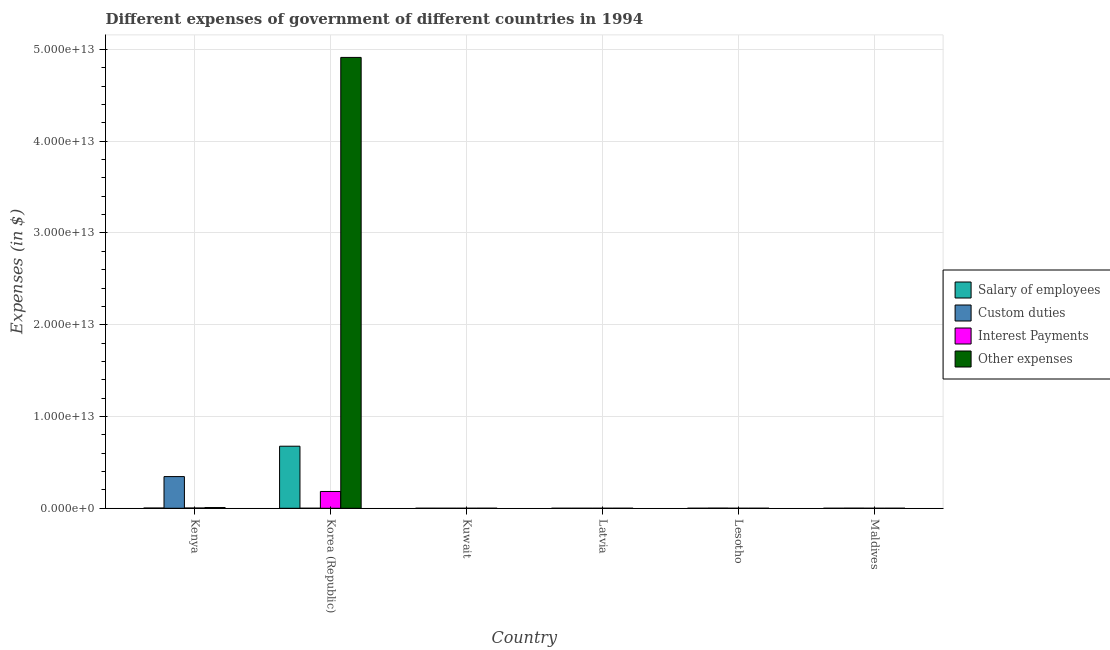How many groups of bars are there?
Your answer should be very brief. 6. What is the label of the 3rd group of bars from the left?
Provide a succinct answer. Kuwait. What is the amount spent on interest payments in Lesotho?
Offer a terse response. 4.94e+07. Across all countries, what is the maximum amount spent on other expenses?
Give a very brief answer. 4.91e+13. Across all countries, what is the minimum amount spent on salary of employees?
Make the answer very short. 9.94e+07. In which country was the amount spent on custom duties maximum?
Provide a succinct answer. Kenya. In which country was the amount spent on interest payments minimum?
Keep it short and to the point. Latvia. What is the total amount spent on other expenses in the graph?
Give a very brief answer. 4.92e+13. What is the difference between the amount spent on salary of employees in Korea (Republic) and that in Lesotho?
Give a very brief answer. 6.76e+12. What is the difference between the amount spent on custom duties in Maldives and the amount spent on salary of employees in Latvia?
Offer a terse response. 7.44e+09. What is the average amount spent on interest payments per country?
Offer a very short reply. 3.10e+11. What is the difference between the amount spent on interest payments and amount spent on custom duties in Maldives?
Offer a very short reply. -7.48e+09. What is the ratio of the amount spent on salary of employees in Kuwait to that in Latvia?
Ensure brevity in your answer.  11.14. Is the difference between the amount spent on other expenses in Kenya and Kuwait greater than the difference between the amount spent on custom duties in Kenya and Kuwait?
Keep it short and to the point. No. What is the difference between the highest and the second highest amount spent on salary of employees?
Provide a succinct answer. 6.74e+12. What is the difference between the highest and the lowest amount spent on interest payments?
Offer a terse response. 1.83e+12. In how many countries, is the amount spent on other expenses greater than the average amount spent on other expenses taken over all countries?
Provide a short and direct response. 1. Is the sum of the amount spent on salary of employees in Kenya and Latvia greater than the maximum amount spent on interest payments across all countries?
Make the answer very short. No. Is it the case that in every country, the sum of the amount spent on interest payments and amount spent on salary of employees is greater than the sum of amount spent on custom duties and amount spent on other expenses?
Keep it short and to the point. No. What does the 2nd bar from the left in Lesotho represents?
Your response must be concise. Custom duties. What does the 2nd bar from the right in Latvia represents?
Ensure brevity in your answer.  Interest Payments. Is it the case that in every country, the sum of the amount spent on salary of employees and amount spent on custom duties is greater than the amount spent on interest payments?
Your answer should be very brief. Yes. Are all the bars in the graph horizontal?
Ensure brevity in your answer.  No. What is the difference between two consecutive major ticks on the Y-axis?
Provide a succinct answer. 1.00e+13. Does the graph contain any zero values?
Your answer should be very brief. No. Where does the legend appear in the graph?
Make the answer very short. Center right. How are the legend labels stacked?
Offer a very short reply. Vertical. What is the title of the graph?
Ensure brevity in your answer.  Different expenses of government of different countries in 1994. Does "Secondary vocational" appear as one of the legend labels in the graph?
Your response must be concise. No. What is the label or title of the Y-axis?
Your response must be concise. Expenses (in $). What is the Expenses (in $) of Salary of employees in Kenya?
Give a very brief answer. 2.49e+1. What is the Expenses (in $) in Custom duties in Kenya?
Make the answer very short. 3.45e+12. What is the Expenses (in $) in Interest Payments in Kenya?
Offer a very short reply. 2.79e+1. What is the Expenses (in $) in Other expenses in Kenya?
Provide a succinct answer. 7.84e+1. What is the Expenses (in $) of Salary of employees in Korea (Republic)?
Offer a very short reply. 6.76e+12. What is the Expenses (in $) of Custom duties in Korea (Republic)?
Offer a terse response. 6.80e+07. What is the Expenses (in $) of Interest Payments in Korea (Republic)?
Your answer should be compact. 1.83e+12. What is the Expenses (in $) of Other expenses in Korea (Republic)?
Give a very brief answer. 4.91e+13. What is the Expenses (in $) of Salary of employees in Kuwait?
Ensure brevity in your answer.  1.11e+09. What is the Expenses (in $) of Custom duties in Kuwait?
Your response must be concise. 2.34e+07. What is the Expenses (in $) in Interest Payments in Kuwait?
Make the answer very short. 3.96e+08. What is the Expenses (in $) in Other expenses in Kuwait?
Offer a terse response. 3.63e+09. What is the Expenses (in $) of Salary of employees in Latvia?
Your answer should be compact. 9.94e+07. What is the Expenses (in $) of Custom duties in Latvia?
Provide a succinct answer. 3.40e+08. What is the Expenses (in $) of Interest Payments in Latvia?
Provide a succinct answer. 8.72e+06. What is the Expenses (in $) in Other expenses in Latvia?
Give a very brief answer. 5.43e+08. What is the Expenses (in $) of Salary of employees in Lesotho?
Provide a short and direct response. 4.60e+08. What is the Expenses (in $) of Custom duties in Lesotho?
Give a very brief answer. 1.27e+1. What is the Expenses (in $) in Interest Payments in Lesotho?
Ensure brevity in your answer.  4.94e+07. What is the Expenses (in $) in Other expenses in Lesotho?
Provide a short and direct response. 1.05e+09. What is the Expenses (in $) in Salary of employees in Maldives?
Keep it short and to the point. 1.85e+08. What is the Expenses (in $) in Custom duties in Maldives?
Keep it short and to the point. 7.54e+09. What is the Expenses (in $) in Interest Payments in Maldives?
Your response must be concise. 5.61e+07. What is the Expenses (in $) of Other expenses in Maldives?
Make the answer very short. 6.92e+08. Across all countries, what is the maximum Expenses (in $) of Salary of employees?
Your answer should be very brief. 6.76e+12. Across all countries, what is the maximum Expenses (in $) of Custom duties?
Your response must be concise. 3.45e+12. Across all countries, what is the maximum Expenses (in $) of Interest Payments?
Your answer should be compact. 1.83e+12. Across all countries, what is the maximum Expenses (in $) in Other expenses?
Your answer should be very brief. 4.91e+13. Across all countries, what is the minimum Expenses (in $) of Salary of employees?
Ensure brevity in your answer.  9.94e+07. Across all countries, what is the minimum Expenses (in $) in Custom duties?
Offer a very short reply. 2.34e+07. Across all countries, what is the minimum Expenses (in $) of Interest Payments?
Ensure brevity in your answer.  8.72e+06. Across all countries, what is the minimum Expenses (in $) of Other expenses?
Offer a very short reply. 5.43e+08. What is the total Expenses (in $) of Salary of employees in the graph?
Ensure brevity in your answer.  6.79e+12. What is the total Expenses (in $) of Custom duties in the graph?
Give a very brief answer. 3.47e+12. What is the total Expenses (in $) of Interest Payments in the graph?
Provide a short and direct response. 1.86e+12. What is the total Expenses (in $) in Other expenses in the graph?
Give a very brief answer. 4.92e+13. What is the difference between the Expenses (in $) in Salary of employees in Kenya and that in Korea (Republic)?
Provide a short and direct response. -6.74e+12. What is the difference between the Expenses (in $) in Custom duties in Kenya and that in Korea (Republic)?
Ensure brevity in your answer.  3.45e+12. What is the difference between the Expenses (in $) in Interest Payments in Kenya and that in Korea (Republic)?
Offer a very short reply. -1.80e+12. What is the difference between the Expenses (in $) in Other expenses in Kenya and that in Korea (Republic)?
Your answer should be compact. -4.90e+13. What is the difference between the Expenses (in $) in Salary of employees in Kenya and that in Kuwait?
Give a very brief answer. 2.38e+1. What is the difference between the Expenses (in $) of Custom duties in Kenya and that in Kuwait?
Provide a short and direct response. 3.45e+12. What is the difference between the Expenses (in $) of Interest Payments in Kenya and that in Kuwait?
Give a very brief answer. 2.75e+1. What is the difference between the Expenses (in $) in Other expenses in Kenya and that in Kuwait?
Give a very brief answer. 7.48e+1. What is the difference between the Expenses (in $) of Salary of employees in Kenya and that in Latvia?
Provide a succinct answer. 2.48e+1. What is the difference between the Expenses (in $) in Custom duties in Kenya and that in Latvia?
Make the answer very short. 3.45e+12. What is the difference between the Expenses (in $) of Interest Payments in Kenya and that in Latvia?
Give a very brief answer. 2.78e+1. What is the difference between the Expenses (in $) in Other expenses in Kenya and that in Latvia?
Keep it short and to the point. 7.79e+1. What is the difference between the Expenses (in $) in Salary of employees in Kenya and that in Lesotho?
Provide a short and direct response. 2.44e+1. What is the difference between the Expenses (in $) in Custom duties in Kenya and that in Lesotho?
Offer a very short reply. 3.44e+12. What is the difference between the Expenses (in $) of Interest Payments in Kenya and that in Lesotho?
Keep it short and to the point. 2.78e+1. What is the difference between the Expenses (in $) in Other expenses in Kenya and that in Lesotho?
Your response must be concise. 7.74e+1. What is the difference between the Expenses (in $) in Salary of employees in Kenya and that in Maldives?
Keep it short and to the point. 2.47e+1. What is the difference between the Expenses (in $) in Custom duties in Kenya and that in Maldives?
Provide a succinct answer. 3.45e+12. What is the difference between the Expenses (in $) in Interest Payments in Kenya and that in Maldives?
Offer a very short reply. 2.78e+1. What is the difference between the Expenses (in $) of Other expenses in Kenya and that in Maldives?
Ensure brevity in your answer.  7.77e+1. What is the difference between the Expenses (in $) in Salary of employees in Korea (Republic) and that in Kuwait?
Your answer should be compact. 6.76e+12. What is the difference between the Expenses (in $) in Custom duties in Korea (Republic) and that in Kuwait?
Your answer should be compact. 4.46e+07. What is the difference between the Expenses (in $) of Interest Payments in Korea (Republic) and that in Kuwait?
Your answer should be compact. 1.83e+12. What is the difference between the Expenses (in $) in Other expenses in Korea (Republic) and that in Kuwait?
Provide a short and direct response. 4.91e+13. What is the difference between the Expenses (in $) of Salary of employees in Korea (Republic) and that in Latvia?
Ensure brevity in your answer.  6.76e+12. What is the difference between the Expenses (in $) of Custom duties in Korea (Republic) and that in Latvia?
Provide a short and direct response. -2.72e+08. What is the difference between the Expenses (in $) of Interest Payments in Korea (Republic) and that in Latvia?
Provide a short and direct response. 1.83e+12. What is the difference between the Expenses (in $) of Other expenses in Korea (Republic) and that in Latvia?
Give a very brief answer. 4.91e+13. What is the difference between the Expenses (in $) of Salary of employees in Korea (Republic) and that in Lesotho?
Your answer should be compact. 6.76e+12. What is the difference between the Expenses (in $) of Custom duties in Korea (Republic) and that in Lesotho?
Keep it short and to the point. -1.26e+1. What is the difference between the Expenses (in $) of Interest Payments in Korea (Republic) and that in Lesotho?
Provide a succinct answer. 1.83e+12. What is the difference between the Expenses (in $) in Other expenses in Korea (Republic) and that in Lesotho?
Provide a succinct answer. 4.91e+13. What is the difference between the Expenses (in $) of Salary of employees in Korea (Republic) and that in Maldives?
Your answer should be very brief. 6.76e+12. What is the difference between the Expenses (in $) of Custom duties in Korea (Republic) and that in Maldives?
Your answer should be compact. -7.47e+09. What is the difference between the Expenses (in $) of Interest Payments in Korea (Republic) and that in Maldives?
Ensure brevity in your answer.  1.83e+12. What is the difference between the Expenses (in $) of Other expenses in Korea (Republic) and that in Maldives?
Offer a very short reply. 4.91e+13. What is the difference between the Expenses (in $) of Salary of employees in Kuwait and that in Latvia?
Give a very brief answer. 1.01e+09. What is the difference between the Expenses (in $) in Custom duties in Kuwait and that in Latvia?
Your response must be concise. -3.17e+08. What is the difference between the Expenses (in $) of Interest Payments in Kuwait and that in Latvia?
Offer a very short reply. 3.87e+08. What is the difference between the Expenses (in $) in Other expenses in Kuwait and that in Latvia?
Provide a short and direct response. 3.09e+09. What is the difference between the Expenses (in $) in Salary of employees in Kuwait and that in Lesotho?
Make the answer very short. 6.48e+08. What is the difference between the Expenses (in $) in Custom duties in Kuwait and that in Lesotho?
Ensure brevity in your answer.  -1.27e+1. What is the difference between the Expenses (in $) in Interest Payments in Kuwait and that in Lesotho?
Make the answer very short. 3.47e+08. What is the difference between the Expenses (in $) of Other expenses in Kuwait and that in Lesotho?
Your answer should be compact. 2.58e+09. What is the difference between the Expenses (in $) of Salary of employees in Kuwait and that in Maldives?
Ensure brevity in your answer.  9.23e+08. What is the difference between the Expenses (in $) of Custom duties in Kuwait and that in Maldives?
Offer a very short reply. -7.52e+09. What is the difference between the Expenses (in $) in Interest Payments in Kuwait and that in Maldives?
Make the answer very short. 3.40e+08. What is the difference between the Expenses (in $) of Other expenses in Kuwait and that in Maldives?
Offer a terse response. 2.94e+09. What is the difference between the Expenses (in $) in Salary of employees in Latvia and that in Lesotho?
Offer a terse response. -3.60e+08. What is the difference between the Expenses (in $) of Custom duties in Latvia and that in Lesotho?
Keep it short and to the point. -1.24e+1. What is the difference between the Expenses (in $) in Interest Payments in Latvia and that in Lesotho?
Offer a very short reply. -4.07e+07. What is the difference between the Expenses (in $) in Other expenses in Latvia and that in Lesotho?
Offer a very short reply. -5.08e+08. What is the difference between the Expenses (in $) in Salary of employees in Latvia and that in Maldives?
Offer a very short reply. -8.55e+07. What is the difference between the Expenses (in $) of Custom duties in Latvia and that in Maldives?
Your response must be concise. -7.20e+09. What is the difference between the Expenses (in $) of Interest Payments in Latvia and that in Maldives?
Make the answer very short. -4.74e+07. What is the difference between the Expenses (in $) of Other expenses in Latvia and that in Maldives?
Your answer should be compact. -1.48e+08. What is the difference between the Expenses (in $) in Salary of employees in Lesotho and that in Maldives?
Keep it short and to the point. 2.75e+08. What is the difference between the Expenses (in $) of Custom duties in Lesotho and that in Maldives?
Provide a succinct answer. 5.17e+09. What is the difference between the Expenses (in $) in Interest Payments in Lesotho and that in Maldives?
Ensure brevity in your answer.  -6.70e+06. What is the difference between the Expenses (in $) of Other expenses in Lesotho and that in Maldives?
Make the answer very short. 3.59e+08. What is the difference between the Expenses (in $) of Salary of employees in Kenya and the Expenses (in $) of Custom duties in Korea (Republic)?
Your response must be concise. 2.48e+1. What is the difference between the Expenses (in $) of Salary of employees in Kenya and the Expenses (in $) of Interest Payments in Korea (Republic)?
Provide a succinct answer. -1.81e+12. What is the difference between the Expenses (in $) of Salary of employees in Kenya and the Expenses (in $) of Other expenses in Korea (Republic)?
Give a very brief answer. -4.91e+13. What is the difference between the Expenses (in $) in Custom duties in Kenya and the Expenses (in $) in Interest Payments in Korea (Republic)?
Offer a very short reply. 1.62e+12. What is the difference between the Expenses (in $) of Custom duties in Kenya and the Expenses (in $) of Other expenses in Korea (Republic)?
Give a very brief answer. -4.57e+13. What is the difference between the Expenses (in $) in Interest Payments in Kenya and the Expenses (in $) in Other expenses in Korea (Republic)?
Offer a very short reply. -4.91e+13. What is the difference between the Expenses (in $) in Salary of employees in Kenya and the Expenses (in $) in Custom duties in Kuwait?
Provide a succinct answer. 2.48e+1. What is the difference between the Expenses (in $) in Salary of employees in Kenya and the Expenses (in $) in Interest Payments in Kuwait?
Make the answer very short. 2.45e+1. What is the difference between the Expenses (in $) of Salary of employees in Kenya and the Expenses (in $) of Other expenses in Kuwait?
Make the answer very short. 2.12e+1. What is the difference between the Expenses (in $) of Custom duties in Kenya and the Expenses (in $) of Interest Payments in Kuwait?
Offer a very short reply. 3.45e+12. What is the difference between the Expenses (in $) of Custom duties in Kenya and the Expenses (in $) of Other expenses in Kuwait?
Your answer should be very brief. 3.45e+12. What is the difference between the Expenses (in $) in Interest Payments in Kenya and the Expenses (in $) in Other expenses in Kuwait?
Offer a terse response. 2.42e+1. What is the difference between the Expenses (in $) in Salary of employees in Kenya and the Expenses (in $) in Custom duties in Latvia?
Offer a very short reply. 2.45e+1. What is the difference between the Expenses (in $) in Salary of employees in Kenya and the Expenses (in $) in Interest Payments in Latvia?
Provide a short and direct response. 2.49e+1. What is the difference between the Expenses (in $) in Salary of employees in Kenya and the Expenses (in $) in Other expenses in Latvia?
Offer a terse response. 2.43e+1. What is the difference between the Expenses (in $) in Custom duties in Kenya and the Expenses (in $) in Interest Payments in Latvia?
Your answer should be compact. 3.45e+12. What is the difference between the Expenses (in $) of Custom duties in Kenya and the Expenses (in $) of Other expenses in Latvia?
Provide a succinct answer. 3.45e+12. What is the difference between the Expenses (in $) in Interest Payments in Kenya and the Expenses (in $) in Other expenses in Latvia?
Make the answer very short. 2.73e+1. What is the difference between the Expenses (in $) in Salary of employees in Kenya and the Expenses (in $) in Custom duties in Lesotho?
Keep it short and to the point. 1.22e+1. What is the difference between the Expenses (in $) of Salary of employees in Kenya and the Expenses (in $) of Interest Payments in Lesotho?
Offer a very short reply. 2.48e+1. What is the difference between the Expenses (in $) of Salary of employees in Kenya and the Expenses (in $) of Other expenses in Lesotho?
Ensure brevity in your answer.  2.38e+1. What is the difference between the Expenses (in $) in Custom duties in Kenya and the Expenses (in $) in Interest Payments in Lesotho?
Offer a very short reply. 3.45e+12. What is the difference between the Expenses (in $) of Custom duties in Kenya and the Expenses (in $) of Other expenses in Lesotho?
Provide a short and direct response. 3.45e+12. What is the difference between the Expenses (in $) of Interest Payments in Kenya and the Expenses (in $) of Other expenses in Lesotho?
Ensure brevity in your answer.  2.68e+1. What is the difference between the Expenses (in $) of Salary of employees in Kenya and the Expenses (in $) of Custom duties in Maldives?
Your answer should be very brief. 1.73e+1. What is the difference between the Expenses (in $) of Salary of employees in Kenya and the Expenses (in $) of Interest Payments in Maldives?
Your answer should be compact. 2.48e+1. What is the difference between the Expenses (in $) of Salary of employees in Kenya and the Expenses (in $) of Other expenses in Maldives?
Your answer should be very brief. 2.42e+1. What is the difference between the Expenses (in $) in Custom duties in Kenya and the Expenses (in $) in Interest Payments in Maldives?
Your response must be concise. 3.45e+12. What is the difference between the Expenses (in $) in Custom duties in Kenya and the Expenses (in $) in Other expenses in Maldives?
Offer a very short reply. 3.45e+12. What is the difference between the Expenses (in $) in Interest Payments in Kenya and the Expenses (in $) in Other expenses in Maldives?
Provide a succinct answer. 2.72e+1. What is the difference between the Expenses (in $) in Salary of employees in Korea (Republic) and the Expenses (in $) in Custom duties in Kuwait?
Your answer should be compact. 6.76e+12. What is the difference between the Expenses (in $) in Salary of employees in Korea (Republic) and the Expenses (in $) in Interest Payments in Kuwait?
Keep it short and to the point. 6.76e+12. What is the difference between the Expenses (in $) of Salary of employees in Korea (Republic) and the Expenses (in $) of Other expenses in Kuwait?
Make the answer very short. 6.76e+12. What is the difference between the Expenses (in $) of Custom duties in Korea (Republic) and the Expenses (in $) of Interest Payments in Kuwait?
Offer a very short reply. -3.28e+08. What is the difference between the Expenses (in $) of Custom duties in Korea (Republic) and the Expenses (in $) of Other expenses in Kuwait?
Provide a short and direct response. -3.57e+09. What is the difference between the Expenses (in $) in Interest Payments in Korea (Republic) and the Expenses (in $) in Other expenses in Kuwait?
Your answer should be very brief. 1.83e+12. What is the difference between the Expenses (in $) of Salary of employees in Korea (Republic) and the Expenses (in $) of Custom duties in Latvia?
Make the answer very short. 6.76e+12. What is the difference between the Expenses (in $) in Salary of employees in Korea (Republic) and the Expenses (in $) in Interest Payments in Latvia?
Keep it short and to the point. 6.76e+12. What is the difference between the Expenses (in $) of Salary of employees in Korea (Republic) and the Expenses (in $) of Other expenses in Latvia?
Your response must be concise. 6.76e+12. What is the difference between the Expenses (in $) in Custom duties in Korea (Republic) and the Expenses (in $) in Interest Payments in Latvia?
Your answer should be compact. 5.93e+07. What is the difference between the Expenses (in $) of Custom duties in Korea (Republic) and the Expenses (in $) of Other expenses in Latvia?
Make the answer very short. -4.75e+08. What is the difference between the Expenses (in $) in Interest Payments in Korea (Republic) and the Expenses (in $) in Other expenses in Latvia?
Your answer should be compact. 1.83e+12. What is the difference between the Expenses (in $) in Salary of employees in Korea (Republic) and the Expenses (in $) in Custom duties in Lesotho?
Give a very brief answer. 6.75e+12. What is the difference between the Expenses (in $) of Salary of employees in Korea (Republic) and the Expenses (in $) of Interest Payments in Lesotho?
Ensure brevity in your answer.  6.76e+12. What is the difference between the Expenses (in $) of Salary of employees in Korea (Republic) and the Expenses (in $) of Other expenses in Lesotho?
Your answer should be compact. 6.76e+12. What is the difference between the Expenses (in $) in Custom duties in Korea (Republic) and the Expenses (in $) in Interest Payments in Lesotho?
Keep it short and to the point. 1.86e+07. What is the difference between the Expenses (in $) of Custom duties in Korea (Republic) and the Expenses (in $) of Other expenses in Lesotho?
Your response must be concise. -9.83e+08. What is the difference between the Expenses (in $) in Interest Payments in Korea (Republic) and the Expenses (in $) in Other expenses in Lesotho?
Your answer should be compact. 1.83e+12. What is the difference between the Expenses (in $) of Salary of employees in Korea (Republic) and the Expenses (in $) of Custom duties in Maldives?
Your answer should be very brief. 6.75e+12. What is the difference between the Expenses (in $) in Salary of employees in Korea (Republic) and the Expenses (in $) in Interest Payments in Maldives?
Give a very brief answer. 6.76e+12. What is the difference between the Expenses (in $) in Salary of employees in Korea (Republic) and the Expenses (in $) in Other expenses in Maldives?
Your answer should be very brief. 6.76e+12. What is the difference between the Expenses (in $) of Custom duties in Korea (Republic) and the Expenses (in $) of Interest Payments in Maldives?
Your response must be concise. 1.19e+07. What is the difference between the Expenses (in $) in Custom duties in Korea (Republic) and the Expenses (in $) in Other expenses in Maldives?
Your answer should be compact. -6.24e+08. What is the difference between the Expenses (in $) in Interest Payments in Korea (Republic) and the Expenses (in $) in Other expenses in Maldives?
Keep it short and to the point. 1.83e+12. What is the difference between the Expenses (in $) in Salary of employees in Kuwait and the Expenses (in $) in Custom duties in Latvia?
Offer a very short reply. 7.68e+08. What is the difference between the Expenses (in $) in Salary of employees in Kuwait and the Expenses (in $) in Interest Payments in Latvia?
Ensure brevity in your answer.  1.10e+09. What is the difference between the Expenses (in $) in Salary of employees in Kuwait and the Expenses (in $) in Other expenses in Latvia?
Your answer should be compact. 5.65e+08. What is the difference between the Expenses (in $) of Custom duties in Kuwait and the Expenses (in $) of Interest Payments in Latvia?
Ensure brevity in your answer.  1.47e+07. What is the difference between the Expenses (in $) of Custom duties in Kuwait and the Expenses (in $) of Other expenses in Latvia?
Ensure brevity in your answer.  -5.20e+08. What is the difference between the Expenses (in $) of Interest Payments in Kuwait and the Expenses (in $) of Other expenses in Latvia?
Make the answer very short. -1.47e+08. What is the difference between the Expenses (in $) of Salary of employees in Kuwait and the Expenses (in $) of Custom duties in Lesotho?
Offer a very short reply. -1.16e+1. What is the difference between the Expenses (in $) in Salary of employees in Kuwait and the Expenses (in $) in Interest Payments in Lesotho?
Keep it short and to the point. 1.06e+09. What is the difference between the Expenses (in $) in Salary of employees in Kuwait and the Expenses (in $) in Other expenses in Lesotho?
Provide a succinct answer. 5.67e+07. What is the difference between the Expenses (in $) in Custom duties in Kuwait and the Expenses (in $) in Interest Payments in Lesotho?
Ensure brevity in your answer.  -2.60e+07. What is the difference between the Expenses (in $) of Custom duties in Kuwait and the Expenses (in $) of Other expenses in Lesotho?
Your answer should be very brief. -1.03e+09. What is the difference between the Expenses (in $) in Interest Payments in Kuwait and the Expenses (in $) in Other expenses in Lesotho?
Give a very brief answer. -6.55e+08. What is the difference between the Expenses (in $) in Salary of employees in Kuwait and the Expenses (in $) in Custom duties in Maldives?
Offer a terse response. -6.43e+09. What is the difference between the Expenses (in $) in Salary of employees in Kuwait and the Expenses (in $) in Interest Payments in Maldives?
Your answer should be very brief. 1.05e+09. What is the difference between the Expenses (in $) in Salary of employees in Kuwait and the Expenses (in $) in Other expenses in Maldives?
Your answer should be compact. 4.16e+08. What is the difference between the Expenses (in $) in Custom duties in Kuwait and the Expenses (in $) in Interest Payments in Maldives?
Provide a succinct answer. -3.27e+07. What is the difference between the Expenses (in $) in Custom duties in Kuwait and the Expenses (in $) in Other expenses in Maldives?
Provide a succinct answer. -6.68e+08. What is the difference between the Expenses (in $) of Interest Payments in Kuwait and the Expenses (in $) of Other expenses in Maldives?
Make the answer very short. -2.96e+08. What is the difference between the Expenses (in $) of Salary of employees in Latvia and the Expenses (in $) of Custom duties in Lesotho?
Ensure brevity in your answer.  -1.26e+1. What is the difference between the Expenses (in $) in Salary of employees in Latvia and the Expenses (in $) in Interest Payments in Lesotho?
Offer a terse response. 5.00e+07. What is the difference between the Expenses (in $) of Salary of employees in Latvia and the Expenses (in $) of Other expenses in Lesotho?
Give a very brief answer. -9.52e+08. What is the difference between the Expenses (in $) of Custom duties in Latvia and the Expenses (in $) of Interest Payments in Lesotho?
Provide a short and direct response. 2.91e+08. What is the difference between the Expenses (in $) of Custom duties in Latvia and the Expenses (in $) of Other expenses in Lesotho?
Keep it short and to the point. -7.11e+08. What is the difference between the Expenses (in $) of Interest Payments in Latvia and the Expenses (in $) of Other expenses in Lesotho?
Your response must be concise. -1.04e+09. What is the difference between the Expenses (in $) of Salary of employees in Latvia and the Expenses (in $) of Custom duties in Maldives?
Your answer should be very brief. -7.44e+09. What is the difference between the Expenses (in $) in Salary of employees in Latvia and the Expenses (in $) in Interest Payments in Maldives?
Your answer should be compact. 4.33e+07. What is the difference between the Expenses (in $) in Salary of employees in Latvia and the Expenses (in $) in Other expenses in Maldives?
Offer a very short reply. -5.92e+08. What is the difference between the Expenses (in $) of Custom duties in Latvia and the Expenses (in $) of Interest Payments in Maldives?
Your answer should be very brief. 2.84e+08. What is the difference between the Expenses (in $) of Custom duties in Latvia and the Expenses (in $) of Other expenses in Maldives?
Provide a succinct answer. -3.52e+08. What is the difference between the Expenses (in $) of Interest Payments in Latvia and the Expenses (in $) of Other expenses in Maldives?
Your answer should be very brief. -6.83e+08. What is the difference between the Expenses (in $) in Salary of employees in Lesotho and the Expenses (in $) in Custom duties in Maldives?
Provide a short and direct response. -7.08e+09. What is the difference between the Expenses (in $) of Salary of employees in Lesotho and the Expenses (in $) of Interest Payments in Maldives?
Offer a terse response. 4.04e+08. What is the difference between the Expenses (in $) of Salary of employees in Lesotho and the Expenses (in $) of Other expenses in Maldives?
Offer a terse response. -2.32e+08. What is the difference between the Expenses (in $) in Custom duties in Lesotho and the Expenses (in $) in Interest Payments in Maldives?
Make the answer very short. 1.27e+1. What is the difference between the Expenses (in $) of Custom duties in Lesotho and the Expenses (in $) of Other expenses in Maldives?
Make the answer very short. 1.20e+1. What is the difference between the Expenses (in $) of Interest Payments in Lesotho and the Expenses (in $) of Other expenses in Maldives?
Make the answer very short. -6.42e+08. What is the average Expenses (in $) in Salary of employees per country?
Your answer should be very brief. 1.13e+12. What is the average Expenses (in $) in Custom duties per country?
Make the answer very short. 5.79e+11. What is the average Expenses (in $) of Interest Payments per country?
Give a very brief answer. 3.10e+11. What is the average Expenses (in $) in Other expenses per country?
Make the answer very short. 8.20e+12. What is the difference between the Expenses (in $) of Salary of employees and Expenses (in $) of Custom duties in Kenya?
Offer a terse response. -3.43e+12. What is the difference between the Expenses (in $) of Salary of employees and Expenses (in $) of Interest Payments in Kenya?
Your response must be concise. -2.99e+09. What is the difference between the Expenses (in $) in Salary of employees and Expenses (in $) in Other expenses in Kenya?
Keep it short and to the point. -5.36e+1. What is the difference between the Expenses (in $) of Custom duties and Expenses (in $) of Interest Payments in Kenya?
Offer a terse response. 3.43e+12. What is the difference between the Expenses (in $) of Custom duties and Expenses (in $) of Other expenses in Kenya?
Your answer should be compact. 3.37e+12. What is the difference between the Expenses (in $) in Interest Payments and Expenses (in $) in Other expenses in Kenya?
Your answer should be very brief. -5.06e+1. What is the difference between the Expenses (in $) of Salary of employees and Expenses (in $) of Custom duties in Korea (Republic)?
Keep it short and to the point. 6.76e+12. What is the difference between the Expenses (in $) in Salary of employees and Expenses (in $) in Interest Payments in Korea (Republic)?
Keep it short and to the point. 4.93e+12. What is the difference between the Expenses (in $) in Salary of employees and Expenses (in $) in Other expenses in Korea (Republic)?
Your answer should be very brief. -4.24e+13. What is the difference between the Expenses (in $) in Custom duties and Expenses (in $) in Interest Payments in Korea (Republic)?
Make the answer very short. -1.83e+12. What is the difference between the Expenses (in $) of Custom duties and Expenses (in $) of Other expenses in Korea (Republic)?
Provide a short and direct response. -4.91e+13. What is the difference between the Expenses (in $) of Interest Payments and Expenses (in $) of Other expenses in Korea (Republic)?
Offer a terse response. -4.73e+13. What is the difference between the Expenses (in $) in Salary of employees and Expenses (in $) in Custom duties in Kuwait?
Provide a succinct answer. 1.08e+09. What is the difference between the Expenses (in $) in Salary of employees and Expenses (in $) in Interest Payments in Kuwait?
Keep it short and to the point. 7.12e+08. What is the difference between the Expenses (in $) of Salary of employees and Expenses (in $) of Other expenses in Kuwait?
Your answer should be very brief. -2.53e+09. What is the difference between the Expenses (in $) of Custom duties and Expenses (in $) of Interest Payments in Kuwait?
Provide a short and direct response. -3.73e+08. What is the difference between the Expenses (in $) in Custom duties and Expenses (in $) in Other expenses in Kuwait?
Keep it short and to the point. -3.61e+09. What is the difference between the Expenses (in $) in Interest Payments and Expenses (in $) in Other expenses in Kuwait?
Your answer should be compact. -3.24e+09. What is the difference between the Expenses (in $) of Salary of employees and Expenses (in $) of Custom duties in Latvia?
Offer a very short reply. -2.41e+08. What is the difference between the Expenses (in $) of Salary of employees and Expenses (in $) of Interest Payments in Latvia?
Keep it short and to the point. 9.07e+07. What is the difference between the Expenses (in $) in Salary of employees and Expenses (in $) in Other expenses in Latvia?
Your answer should be very brief. -4.44e+08. What is the difference between the Expenses (in $) of Custom duties and Expenses (in $) of Interest Payments in Latvia?
Provide a succinct answer. 3.31e+08. What is the difference between the Expenses (in $) of Custom duties and Expenses (in $) of Other expenses in Latvia?
Provide a short and direct response. -2.03e+08. What is the difference between the Expenses (in $) in Interest Payments and Expenses (in $) in Other expenses in Latvia?
Keep it short and to the point. -5.35e+08. What is the difference between the Expenses (in $) of Salary of employees and Expenses (in $) of Custom duties in Lesotho?
Provide a succinct answer. -1.22e+1. What is the difference between the Expenses (in $) of Salary of employees and Expenses (in $) of Interest Payments in Lesotho?
Keep it short and to the point. 4.10e+08. What is the difference between the Expenses (in $) in Salary of employees and Expenses (in $) in Other expenses in Lesotho?
Give a very brief answer. -5.92e+08. What is the difference between the Expenses (in $) in Custom duties and Expenses (in $) in Interest Payments in Lesotho?
Your response must be concise. 1.27e+1. What is the difference between the Expenses (in $) of Custom duties and Expenses (in $) of Other expenses in Lesotho?
Give a very brief answer. 1.17e+1. What is the difference between the Expenses (in $) in Interest Payments and Expenses (in $) in Other expenses in Lesotho?
Your answer should be very brief. -1.00e+09. What is the difference between the Expenses (in $) of Salary of employees and Expenses (in $) of Custom duties in Maldives?
Ensure brevity in your answer.  -7.36e+09. What is the difference between the Expenses (in $) in Salary of employees and Expenses (in $) in Interest Payments in Maldives?
Offer a terse response. 1.29e+08. What is the difference between the Expenses (in $) of Salary of employees and Expenses (in $) of Other expenses in Maldives?
Your answer should be very brief. -5.07e+08. What is the difference between the Expenses (in $) of Custom duties and Expenses (in $) of Interest Payments in Maldives?
Offer a very short reply. 7.48e+09. What is the difference between the Expenses (in $) of Custom duties and Expenses (in $) of Other expenses in Maldives?
Offer a very short reply. 6.85e+09. What is the difference between the Expenses (in $) in Interest Payments and Expenses (in $) in Other expenses in Maldives?
Your response must be concise. -6.36e+08. What is the ratio of the Expenses (in $) of Salary of employees in Kenya to that in Korea (Republic)?
Make the answer very short. 0. What is the ratio of the Expenses (in $) in Custom duties in Kenya to that in Korea (Republic)?
Give a very brief answer. 5.08e+04. What is the ratio of the Expenses (in $) of Interest Payments in Kenya to that in Korea (Republic)?
Provide a short and direct response. 0.02. What is the ratio of the Expenses (in $) of Other expenses in Kenya to that in Korea (Republic)?
Give a very brief answer. 0. What is the ratio of the Expenses (in $) in Salary of employees in Kenya to that in Kuwait?
Keep it short and to the point. 22.44. What is the ratio of the Expenses (in $) of Custom duties in Kenya to that in Kuwait?
Ensure brevity in your answer.  1.48e+05. What is the ratio of the Expenses (in $) in Interest Payments in Kenya to that in Kuwait?
Your response must be concise. 70.34. What is the ratio of the Expenses (in $) in Other expenses in Kenya to that in Kuwait?
Your answer should be compact. 21.58. What is the ratio of the Expenses (in $) of Salary of employees in Kenya to that in Latvia?
Make the answer very short. 250.06. What is the ratio of the Expenses (in $) of Custom duties in Kenya to that in Latvia?
Provide a succinct answer. 1.01e+04. What is the ratio of the Expenses (in $) of Interest Payments in Kenya to that in Latvia?
Provide a short and direct response. 3194.15. What is the ratio of the Expenses (in $) of Other expenses in Kenya to that in Latvia?
Make the answer very short. 144.33. What is the ratio of the Expenses (in $) of Salary of employees in Kenya to that in Lesotho?
Offer a terse response. 54.08. What is the ratio of the Expenses (in $) in Custom duties in Kenya to that in Lesotho?
Make the answer very short. 271.72. What is the ratio of the Expenses (in $) in Interest Payments in Kenya to that in Lesotho?
Make the answer very short. 563.83. What is the ratio of the Expenses (in $) of Other expenses in Kenya to that in Lesotho?
Provide a short and direct response. 74.61. What is the ratio of the Expenses (in $) of Salary of employees in Kenya to that in Maldives?
Ensure brevity in your answer.  134.46. What is the ratio of the Expenses (in $) in Custom duties in Kenya to that in Maldives?
Your response must be concise. 457.9. What is the ratio of the Expenses (in $) of Interest Payments in Kenya to that in Maldives?
Offer a terse response. 496.49. What is the ratio of the Expenses (in $) in Other expenses in Kenya to that in Maldives?
Offer a very short reply. 113.36. What is the ratio of the Expenses (in $) of Salary of employees in Korea (Republic) to that in Kuwait?
Your answer should be compact. 6102.89. What is the ratio of the Expenses (in $) in Custom duties in Korea (Republic) to that in Kuwait?
Make the answer very short. 2.9. What is the ratio of the Expenses (in $) in Interest Payments in Korea (Republic) to that in Kuwait?
Ensure brevity in your answer.  4621.21. What is the ratio of the Expenses (in $) in Other expenses in Korea (Republic) to that in Kuwait?
Provide a succinct answer. 1.35e+04. What is the ratio of the Expenses (in $) in Salary of employees in Korea (Republic) to that in Latvia?
Keep it short and to the point. 6.80e+04. What is the ratio of the Expenses (in $) in Custom duties in Korea (Republic) to that in Latvia?
Your answer should be compact. 0.2. What is the ratio of the Expenses (in $) of Interest Payments in Korea (Republic) to that in Latvia?
Ensure brevity in your answer.  2.10e+05. What is the ratio of the Expenses (in $) of Other expenses in Korea (Republic) to that in Latvia?
Your answer should be very brief. 9.04e+04. What is the ratio of the Expenses (in $) in Salary of employees in Korea (Republic) to that in Lesotho?
Offer a terse response. 1.47e+04. What is the ratio of the Expenses (in $) in Custom duties in Korea (Republic) to that in Lesotho?
Provide a short and direct response. 0.01. What is the ratio of the Expenses (in $) of Interest Payments in Korea (Republic) to that in Lesotho?
Your answer should be compact. 3.70e+04. What is the ratio of the Expenses (in $) in Other expenses in Korea (Republic) to that in Lesotho?
Your answer should be very brief. 4.67e+04. What is the ratio of the Expenses (in $) in Salary of employees in Korea (Republic) to that in Maldives?
Provide a succinct answer. 3.66e+04. What is the ratio of the Expenses (in $) in Custom duties in Korea (Republic) to that in Maldives?
Your response must be concise. 0.01. What is the ratio of the Expenses (in $) of Interest Payments in Korea (Republic) to that in Maldives?
Provide a short and direct response. 3.26e+04. What is the ratio of the Expenses (in $) of Other expenses in Korea (Republic) to that in Maldives?
Give a very brief answer. 7.10e+04. What is the ratio of the Expenses (in $) of Salary of employees in Kuwait to that in Latvia?
Offer a terse response. 11.14. What is the ratio of the Expenses (in $) of Custom duties in Kuwait to that in Latvia?
Provide a short and direct response. 0.07. What is the ratio of the Expenses (in $) of Interest Payments in Kuwait to that in Latvia?
Keep it short and to the point. 45.41. What is the ratio of the Expenses (in $) in Other expenses in Kuwait to that in Latvia?
Keep it short and to the point. 6.69. What is the ratio of the Expenses (in $) of Salary of employees in Kuwait to that in Lesotho?
Your response must be concise. 2.41. What is the ratio of the Expenses (in $) in Custom duties in Kuwait to that in Lesotho?
Make the answer very short. 0. What is the ratio of the Expenses (in $) in Interest Payments in Kuwait to that in Lesotho?
Offer a terse response. 8.02. What is the ratio of the Expenses (in $) in Other expenses in Kuwait to that in Lesotho?
Your answer should be very brief. 3.46. What is the ratio of the Expenses (in $) in Salary of employees in Kuwait to that in Maldives?
Your response must be concise. 5.99. What is the ratio of the Expenses (in $) of Custom duties in Kuwait to that in Maldives?
Your answer should be very brief. 0. What is the ratio of the Expenses (in $) in Interest Payments in Kuwait to that in Maldives?
Your answer should be compact. 7.06. What is the ratio of the Expenses (in $) in Other expenses in Kuwait to that in Maldives?
Keep it short and to the point. 5.25. What is the ratio of the Expenses (in $) of Salary of employees in Latvia to that in Lesotho?
Provide a succinct answer. 0.22. What is the ratio of the Expenses (in $) of Custom duties in Latvia to that in Lesotho?
Your answer should be very brief. 0.03. What is the ratio of the Expenses (in $) of Interest Payments in Latvia to that in Lesotho?
Offer a very short reply. 0.18. What is the ratio of the Expenses (in $) in Other expenses in Latvia to that in Lesotho?
Provide a succinct answer. 0.52. What is the ratio of the Expenses (in $) of Salary of employees in Latvia to that in Maldives?
Your response must be concise. 0.54. What is the ratio of the Expenses (in $) in Custom duties in Latvia to that in Maldives?
Your answer should be very brief. 0.05. What is the ratio of the Expenses (in $) of Interest Payments in Latvia to that in Maldives?
Provide a short and direct response. 0.16. What is the ratio of the Expenses (in $) in Other expenses in Latvia to that in Maldives?
Your answer should be very brief. 0.79. What is the ratio of the Expenses (in $) of Salary of employees in Lesotho to that in Maldives?
Keep it short and to the point. 2.49. What is the ratio of the Expenses (in $) of Custom duties in Lesotho to that in Maldives?
Offer a terse response. 1.69. What is the ratio of the Expenses (in $) in Interest Payments in Lesotho to that in Maldives?
Your answer should be very brief. 0.88. What is the ratio of the Expenses (in $) in Other expenses in Lesotho to that in Maldives?
Ensure brevity in your answer.  1.52. What is the difference between the highest and the second highest Expenses (in $) in Salary of employees?
Your response must be concise. 6.74e+12. What is the difference between the highest and the second highest Expenses (in $) of Custom duties?
Your answer should be compact. 3.44e+12. What is the difference between the highest and the second highest Expenses (in $) of Interest Payments?
Your response must be concise. 1.80e+12. What is the difference between the highest and the second highest Expenses (in $) of Other expenses?
Provide a succinct answer. 4.90e+13. What is the difference between the highest and the lowest Expenses (in $) in Salary of employees?
Keep it short and to the point. 6.76e+12. What is the difference between the highest and the lowest Expenses (in $) of Custom duties?
Your answer should be very brief. 3.45e+12. What is the difference between the highest and the lowest Expenses (in $) of Interest Payments?
Give a very brief answer. 1.83e+12. What is the difference between the highest and the lowest Expenses (in $) of Other expenses?
Offer a very short reply. 4.91e+13. 